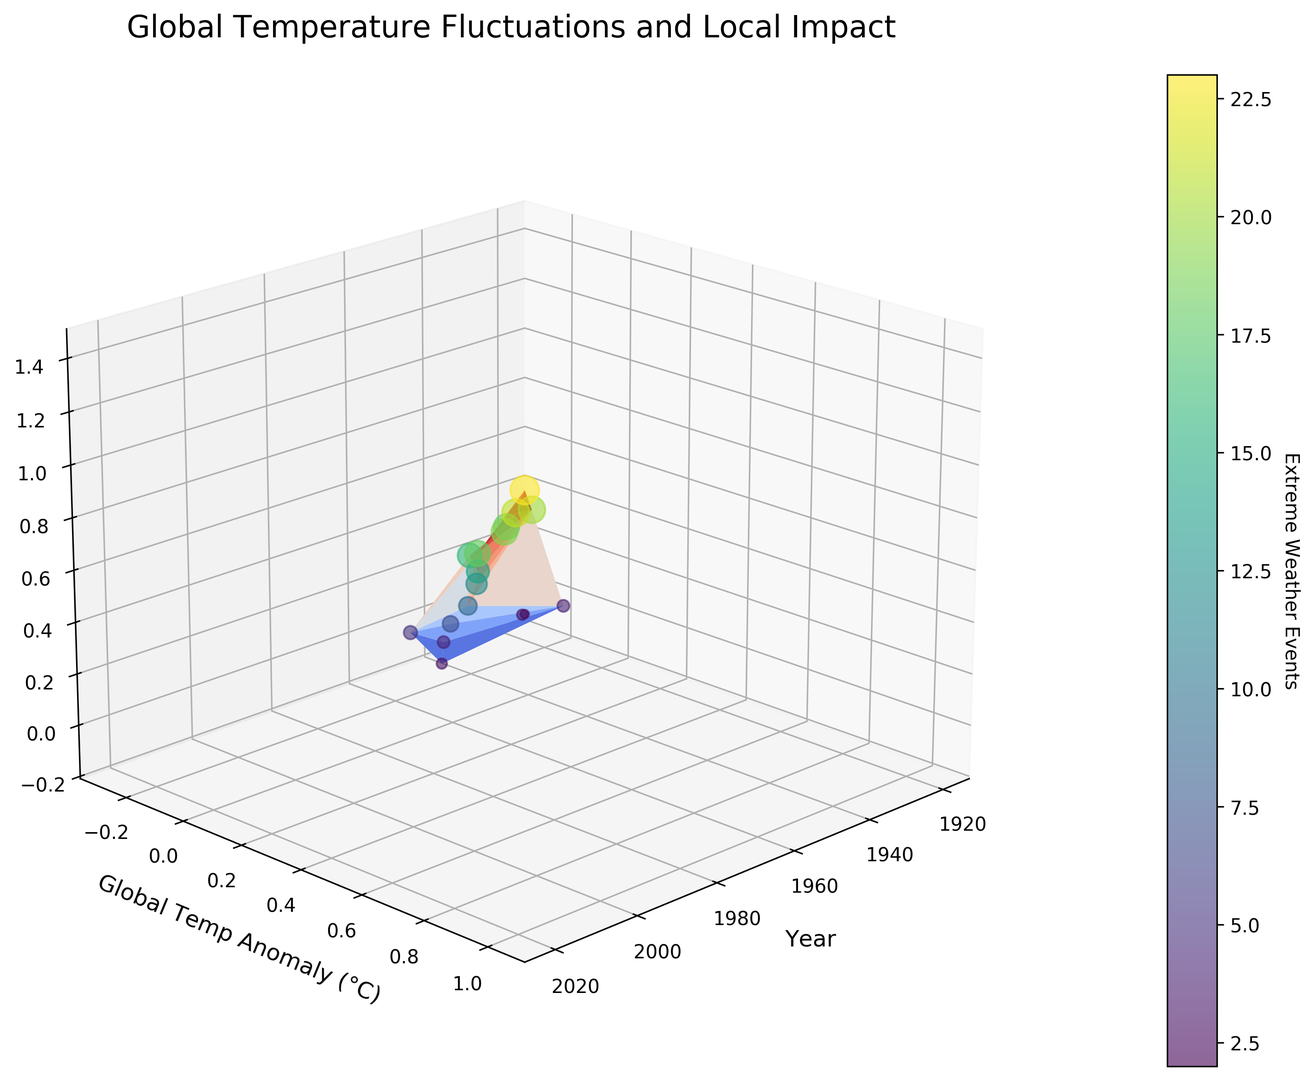What year experienced the highest local temperature change and how does it relate to the number of extreme weather events? By examining the plot, the year with the highest local temperature change (1.4 °C) can be identified visually, which is 2020. Cross-referencing it with the size of the scatter points or color intensity reveals that it corresponds to 23 extreme weather events.
Answer: 2020, 23 In which year did the global temperature anomaly exceed 0.5°C for the first time, and what was the corresponding local temperature change that year? Looking at the 3D surface plot, the global temperature anomaly first exceeds 0.5°C in the year 2000. The corresponding local temperature change can be visually inspected on the graph to be 0.8°C.
Answer: 2000, 0.8°C What is the trend in the number of extreme weather events as the global temperature anomaly increases from 1980 to 2020? First, identify the years from 1980 to 2020. Then observe the number of extreme weather events for these years. It can be observed that as the global temperature anomaly increases from 0.26°C in 1980 to 1.02°C in 2020, the number of extreme weather events also increases from 7 to 23.
Answer: Increasing trend Compare the local temperature change between 1970 and 1980. Which year had a higher local temperature change and by how much? Inspecting the plot, the local temperature change in 1970 is 0.2°C and in 1980 it is 0.4°C. Subtracting these, 1980 had a 0.2°C higher temperature change than 1970.
Answer: 1980 by 0.2°C How did the number of extreme weather events change between the years 2010 and 2015? Visually compare the year 2010 with 16 events and the year 2015 with 18 events by checking the size and color of the scatter points. The number of extreme weather events increased by 2 from 2010 to 2015.
Answer: Increased by 2 What is the average number of extreme weather events in the 2010s (2010-2020)? Identify the number of extreme weather events in the years 2010, 2015, 2016, 2017, 2018, 2019, and 2020 which are 16, 18, 20, 19, 18, 21, and 23 respectively. Compute the average (16+18+20+19+18+21+23)/7 = 135/7 ≈ 19.29
Answer: 19.29 Between which consecutive decades did the largest increase in the global temperature anomaly occur? Compare the global temperature anomaly increments for each decade pair: 1920-1930, 1930-1940, 1940-1950, and so on. The largest increase is noticeable between 1980-1990 (0.19°C) and 2000-2010 (0.11°C), with the largest jump between 1970-1980 and 1980-1990.
Answer: 1970-1980 to 1980-1990 